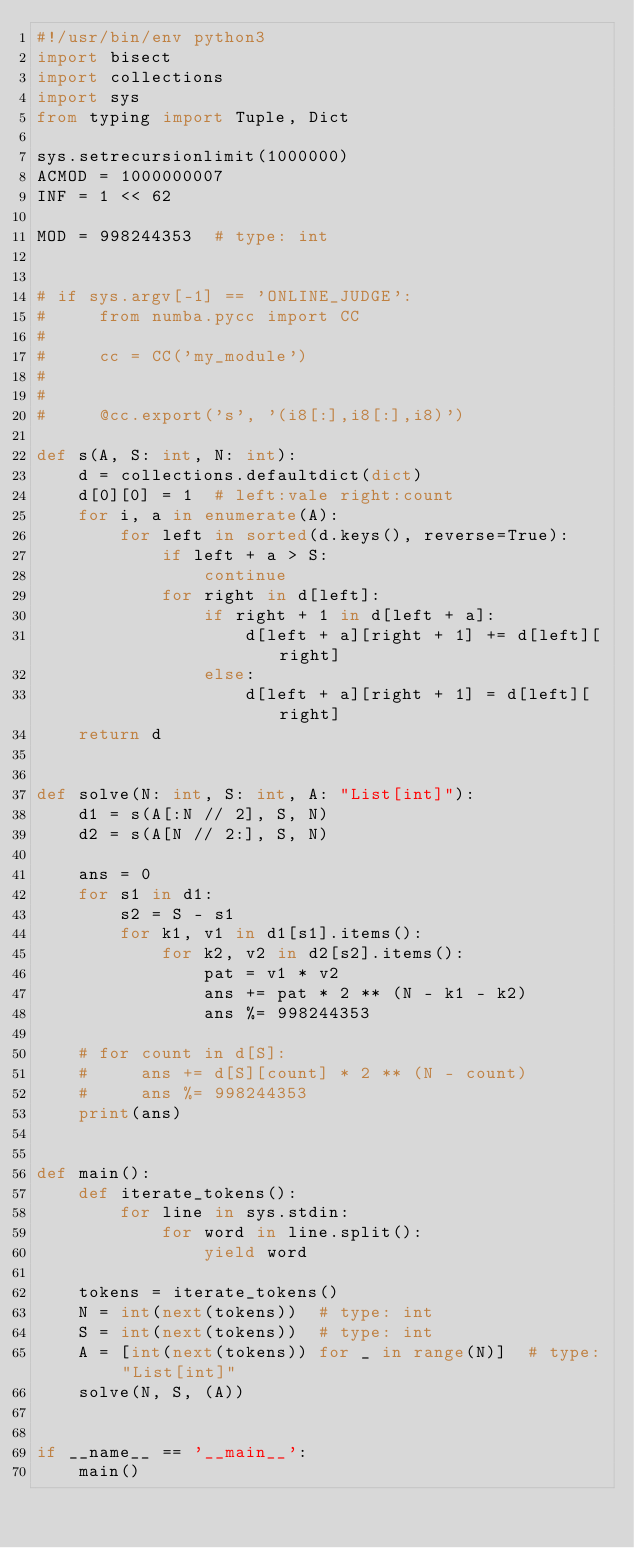Convert code to text. <code><loc_0><loc_0><loc_500><loc_500><_Python_>#!/usr/bin/env python3
import bisect
import collections
import sys
from typing import Tuple, Dict

sys.setrecursionlimit(1000000)
ACMOD = 1000000007
INF = 1 << 62

MOD = 998244353  # type: int


# if sys.argv[-1] == 'ONLINE_JUDGE':
#     from numba.pycc import CC
#
#     cc = CC('my_module')
#
#
#     @cc.export('s', '(i8[:],i8[:],i8)')

def s(A, S: int, N: int):
    d = collections.defaultdict(dict)
    d[0][0] = 1  # left:vale right:count
    for i, a in enumerate(A):
        for left in sorted(d.keys(), reverse=True):
            if left + a > S:
                continue
            for right in d[left]:
                if right + 1 in d[left + a]:
                    d[left + a][right + 1] += d[left][right]
                else:
                    d[left + a][right + 1] = d[left][right]
    return d


def solve(N: int, S: int, A: "List[int]"):
    d1 = s(A[:N // 2], S, N)
    d2 = s(A[N // 2:], S, N)

    ans = 0
    for s1 in d1:
        s2 = S - s1
        for k1, v1 in d1[s1].items():
            for k2, v2 in d2[s2].items():
                pat = v1 * v2
                ans += pat * 2 ** (N - k1 - k2)
                ans %= 998244353

    # for count in d[S]:
    #     ans += d[S][count] * 2 ** (N - count)
    #     ans %= 998244353
    print(ans)


def main():
    def iterate_tokens():
        for line in sys.stdin:
            for word in line.split():
                yield word

    tokens = iterate_tokens()
    N = int(next(tokens))  # type: int
    S = int(next(tokens))  # type: int
    A = [int(next(tokens)) for _ in range(N)]  # type: "List[int]"
    solve(N, S, (A))


if __name__ == '__main__':
    main()
</code> 